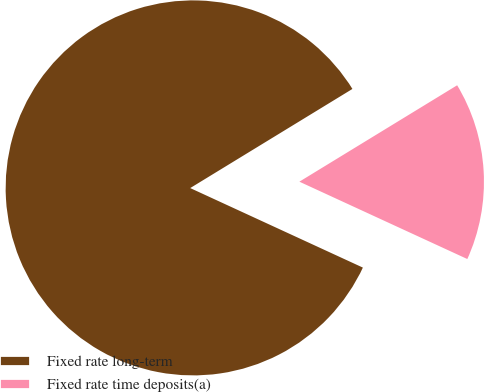Convert chart. <chart><loc_0><loc_0><loc_500><loc_500><pie_chart><fcel>Fixed rate long-term<fcel>Fixed rate time deposits(a)<nl><fcel>84.4%<fcel>15.6%<nl></chart> 